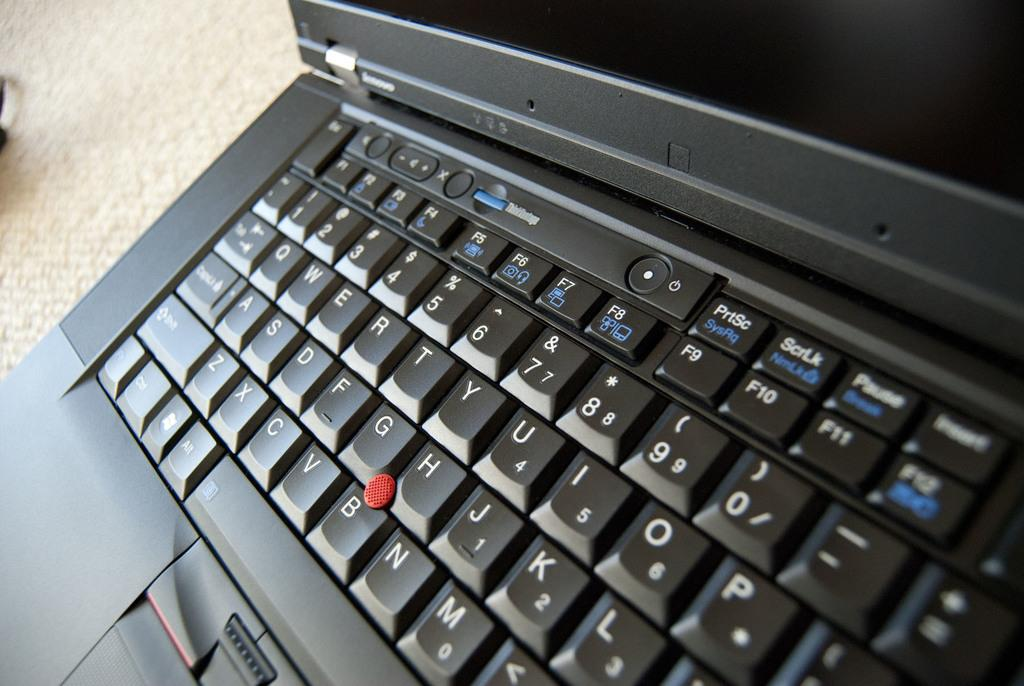<image>
Create a compact narrative representing the image presented. A red dot button between the G,H,B keys. 